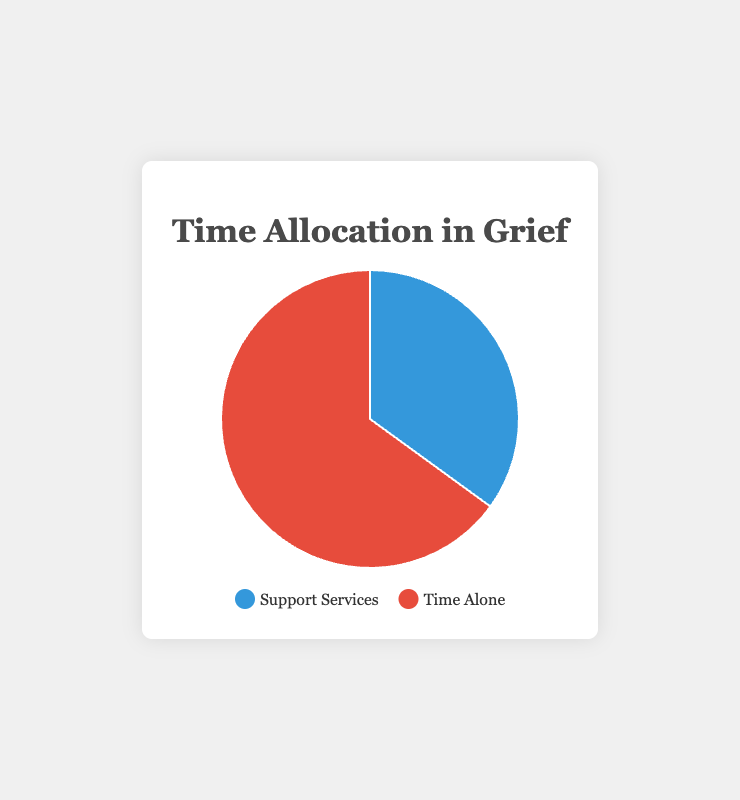Which activity takes up the larger portion of the pie chart? The chart shows percentages for two activities: Time Spent on Support Services and Time Spent Alone. By comparing the two, Time Spent Alone accounts for 65%, whereas Time Spent on Support Services accounts for 35%. Therefore, Time Spent Alone takes up the larger portion.
Answer: Time Spent Alone How much more time is spent alone compared to support services? Time Spent Alone is 65% and Time Spent on Support Services is 35%. To find the difference, subtract the smaller percentage from the larger one: 65% - 35% = 30%.
Answer: 30% What percentage of time is not spent alone? The pie chart shows Time Spent on Support Services and Time Spent Alone. Since Time Spent Alone is 65%, the percentage of time not spent alone is 100% - 65% = 35%, which corresponds to the Time Spent on Support Services.
Answer: 35% What fraction of time is spent on support services? From the pie chart, Time Spent on Support Services is given as 35%. This percentage can be converted to a fraction by dividing by 100: 35/100 = 7/20 when simplified.
Answer: 7/20 If you were to double the time spent on support services, what would the new percentage be? Currently, Time Spent on Support Services is 35%. Doubling this gives 35% * 2 = 70%. However, as the total must still add up to 100%, the remaining percentage for Time Spent Alone would be reduced accordingly to 30%.
Answer: 70% What colors represent the two activities in the pie chart? The pie chart uses two colors to distinguish between the activities: blue represents Time Spent on Support Services, and red represents Time Spent Alone.
Answer: Blue and Red If the time spent on support services decreased by 10%, what would the new percentage be? Time Spent on Support Services is currently 35%. A decrease of 10% of this value is calculated as 35% * 0.10 = 3.5%. Subtracting this from the current percentage gives 35% - 3.5% = 31.5%. Therefore, the new percentage for Time Spent on Support Services would be 31.5%.
Answer: 31.5% What is the combined percentage of time spent on activities other than being alone? The pie chart shows Time Spent on Support Services as the only other activity. Thus, the percentage of time spent on activities other than being alone is the same as the Time Spent on Support Services, which is 35%.
Answer: 35% How does the visual size of the blue section compare to the red section? The blue section represents Time Spent on Support Services at 35%, and the red section represents Time Spent Alone at 65%. Since 65% is nearly double 35%, the red section (Time Spent Alone) appears almost twice as large as the blue section (Time Spent on Support Services).
Answer: The red section is almost twice as large 